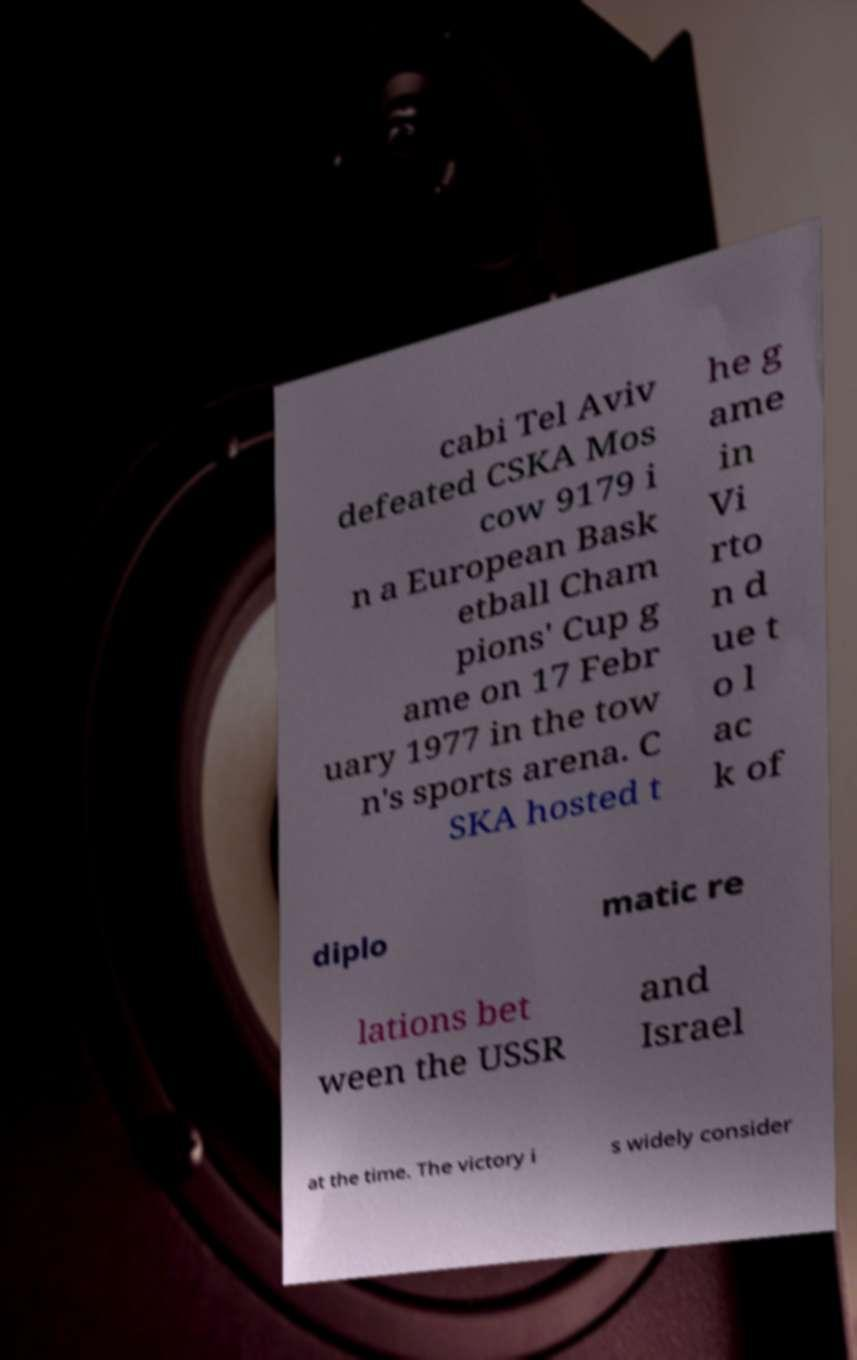Can you read and provide the text displayed in the image?This photo seems to have some interesting text. Can you extract and type it out for me? cabi Tel Aviv defeated CSKA Mos cow 9179 i n a European Bask etball Cham pions' Cup g ame on 17 Febr uary 1977 in the tow n's sports arena. C SKA hosted t he g ame in Vi rto n d ue t o l ac k of diplo matic re lations bet ween the USSR and Israel at the time. The victory i s widely consider 